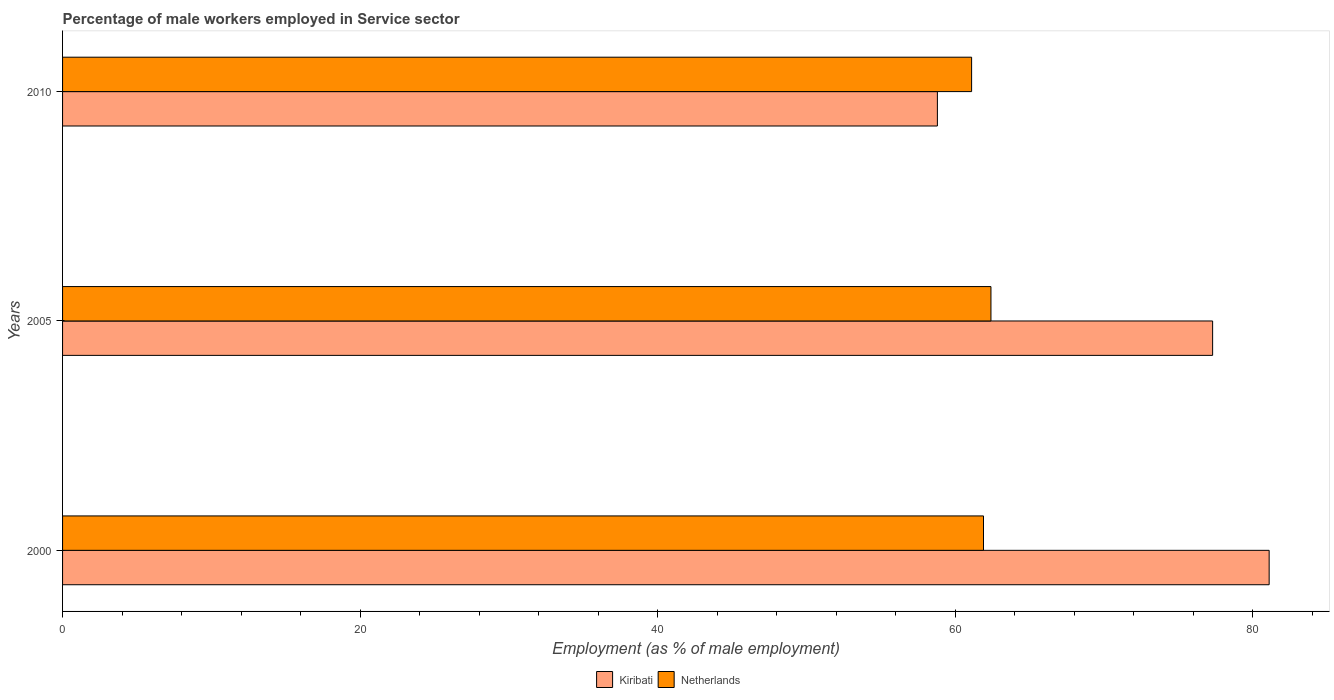How many groups of bars are there?
Offer a terse response. 3. Are the number of bars on each tick of the Y-axis equal?
Your response must be concise. Yes. What is the label of the 2nd group of bars from the top?
Provide a short and direct response. 2005. In how many cases, is the number of bars for a given year not equal to the number of legend labels?
Your answer should be compact. 0. What is the percentage of male workers employed in Service sector in Kiribati in 2010?
Offer a terse response. 58.8. Across all years, what is the maximum percentage of male workers employed in Service sector in Kiribati?
Offer a very short reply. 81.1. Across all years, what is the minimum percentage of male workers employed in Service sector in Kiribati?
Your answer should be compact. 58.8. In which year was the percentage of male workers employed in Service sector in Kiribati maximum?
Make the answer very short. 2000. In which year was the percentage of male workers employed in Service sector in Netherlands minimum?
Your answer should be very brief. 2010. What is the total percentage of male workers employed in Service sector in Kiribati in the graph?
Provide a succinct answer. 217.2. What is the difference between the percentage of male workers employed in Service sector in Netherlands in 2005 and that in 2010?
Make the answer very short. 1.3. What is the difference between the percentage of male workers employed in Service sector in Kiribati in 2010 and the percentage of male workers employed in Service sector in Netherlands in 2000?
Provide a succinct answer. -3.1. What is the average percentage of male workers employed in Service sector in Netherlands per year?
Your response must be concise. 61.8. In the year 2005, what is the difference between the percentage of male workers employed in Service sector in Netherlands and percentage of male workers employed in Service sector in Kiribati?
Your answer should be compact. -14.9. What is the ratio of the percentage of male workers employed in Service sector in Netherlands in 2000 to that in 2005?
Offer a terse response. 0.99. What is the difference between the highest and the second highest percentage of male workers employed in Service sector in Netherlands?
Offer a very short reply. 0.5. What is the difference between the highest and the lowest percentage of male workers employed in Service sector in Kiribati?
Your answer should be compact. 22.3. Is the sum of the percentage of male workers employed in Service sector in Kiribati in 2005 and 2010 greater than the maximum percentage of male workers employed in Service sector in Netherlands across all years?
Offer a terse response. Yes. What does the 2nd bar from the top in 2005 represents?
Keep it short and to the point. Kiribati. What does the 2nd bar from the bottom in 2005 represents?
Make the answer very short. Netherlands. How many bars are there?
Your answer should be compact. 6. Are the values on the major ticks of X-axis written in scientific E-notation?
Offer a terse response. No. Does the graph contain grids?
Offer a terse response. No. Where does the legend appear in the graph?
Offer a terse response. Bottom center. How many legend labels are there?
Your answer should be compact. 2. What is the title of the graph?
Keep it short and to the point. Percentage of male workers employed in Service sector. Does "Arab World" appear as one of the legend labels in the graph?
Give a very brief answer. No. What is the label or title of the X-axis?
Your response must be concise. Employment (as % of male employment). What is the Employment (as % of male employment) in Kiribati in 2000?
Make the answer very short. 81.1. What is the Employment (as % of male employment) in Netherlands in 2000?
Your answer should be compact. 61.9. What is the Employment (as % of male employment) of Kiribati in 2005?
Provide a succinct answer. 77.3. What is the Employment (as % of male employment) in Netherlands in 2005?
Ensure brevity in your answer.  62.4. What is the Employment (as % of male employment) in Kiribati in 2010?
Your response must be concise. 58.8. What is the Employment (as % of male employment) in Netherlands in 2010?
Make the answer very short. 61.1. Across all years, what is the maximum Employment (as % of male employment) of Kiribati?
Make the answer very short. 81.1. Across all years, what is the maximum Employment (as % of male employment) of Netherlands?
Provide a succinct answer. 62.4. Across all years, what is the minimum Employment (as % of male employment) in Kiribati?
Provide a short and direct response. 58.8. Across all years, what is the minimum Employment (as % of male employment) in Netherlands?
Offer a very short reply. 61.1. What is the total Employment (as % of male employment) in Kiribati in the graph?
Ensure brevity in your answer.  217.2. What is the total Employment (as % of male employment) in Netherlands in the graph?
Offer a very short reply. 185.4. What is the difference between the Employment (as % of male employment) of Netherlands in 2000 and that in 2005?
Make the answer very short. -0.5. What is the difference between the Employment (as % of male employment) in Kiribati in 2000 and that in 2010?
Ensure brevity in your answer.  22.3. What is the difference between the Employment (as % of male employment) of Netherlands in 2005 and that in 2010?
Make the answer very short. 1.3. What is the difference between the Employment (as % of male employment) of Kiribati in 2005 and the Employment (as % of male employment) of Netherlands in 2010?
Your answer should be very brief. 16.2. What is the average Employment (as % of male employment) of Kiribati per year?
Offer a very short reply. 72.4. What is the average Employment (as % of male employment) in Netherlands per year?
Offer a very short reply. 61.8. In the year 2000, what is the difference between the Employment (as % of male employment) of Kiribati and Employment (as % of male employment) of Netherlands?
Your answer should be very brief. 19.2. In the year 2010, what is the difference between the Employment (as % of male employment) in Kiribati and Employment (as % of male employment) in Netherlands?
Offer a very short reply. -2.3. What is the ratio of the Employment (as % of male employment) of Kiribati in 2000 to that in 2005?
Your answer should be very brief. 1.05. What is the ratio of the Employment (as % of male employment) in Netherlands in 2000 to that in 2005?
Provide a succinct answer. 0.99. What is the ratio of the Employment (as % of male employment) in Kiribati in 2000 to that in 2010?
Make the answer very short. 1.38. What is the ratio of the Employment (as % of male employment) in Netherlands in 2000 to that in 2010?
Provide a short and direct response. 1.01. What is the ratio of the Employment (as % of male employment) of Kiribati in 2005 to that in 2010?
Provide a short and direct response. 1.31. What is the ratio of the Employment (as % of male employment) of Netherlands in 2005 to that in 2010?
Keep it short and to the point. 1.02. What is the difference between the highest and the second highest Employment (as % of male employment) in Netherlands?
Keep it short and to the point. 0.5. What is the difference between the highest and the lowest Employment (as % of male employment) of Kiribati?
Your answer should be very brief. 22.3. 